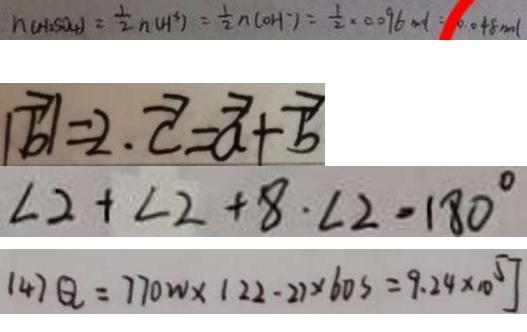<formula> <loc_0><loc_0><loc_500><loc_500>n ( H _ { 2 } S O _ { 4 } ) = \frac { 1 } { 2 } n ( H ^ { 3 } ) = \frac { 1 } { 2 } n ( O H ) = \frac { 1 } { 2 } \times 0 . 0 9 6 m l = 0 . 0 4 8 m o l 
 \vert \overrightarrow { b } \vert = 2 \cdot \overrightarrow { c } = \overrightarrow { a } + \overrightarrow { b } 
 \angle 2 + \angle 2 + 8 \cdot \angle 2 = 1 8 0 ^ { \circ } 
 ( 4 ) Q = 7 7 0 w \times ( 2 2 - 2 ) \times 6 0 s = 9 . 2 4 \times 1 0 ^ { 5 } J</formula> 